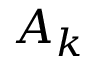<formula> <loc_0><loc_0><loc_500><loc_500>A _ { k } }</formula> 